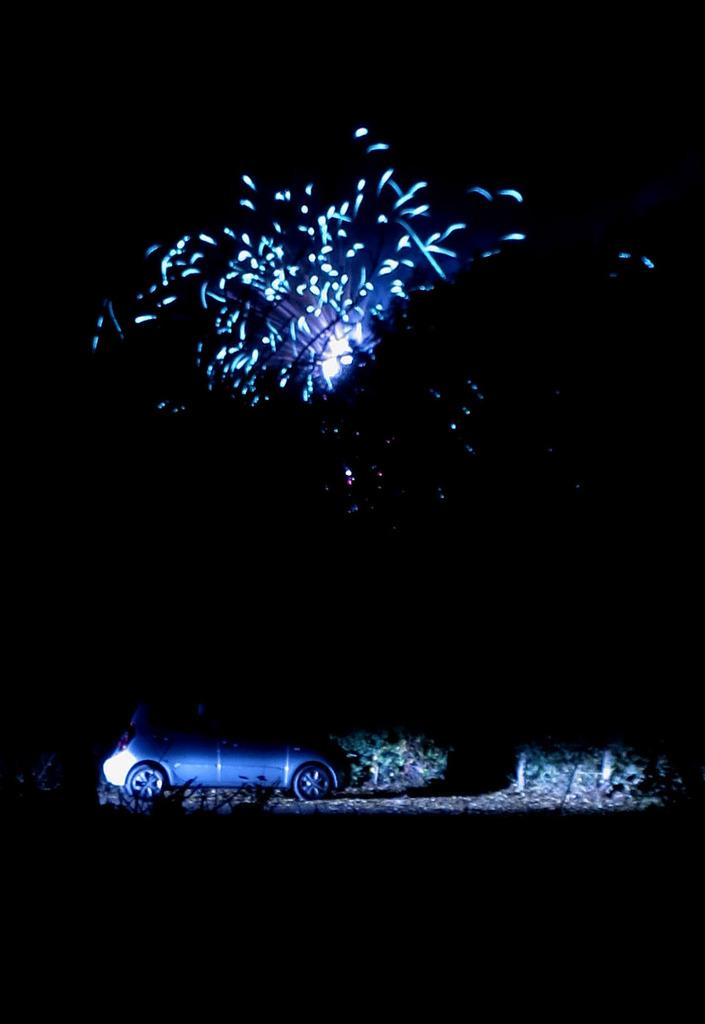What is the main subject in the center of the image? There is a car in the center of the image. What can be seen in the background of the image? There are trees and lights visible in the background of the image. What type of dirt can be seen on the car's tires in the image? There is no dirt visible on the car's tires in the image. How much wax is being applied to the car in the image? There is no wax application visible in the image; it only shows the car and the background. 